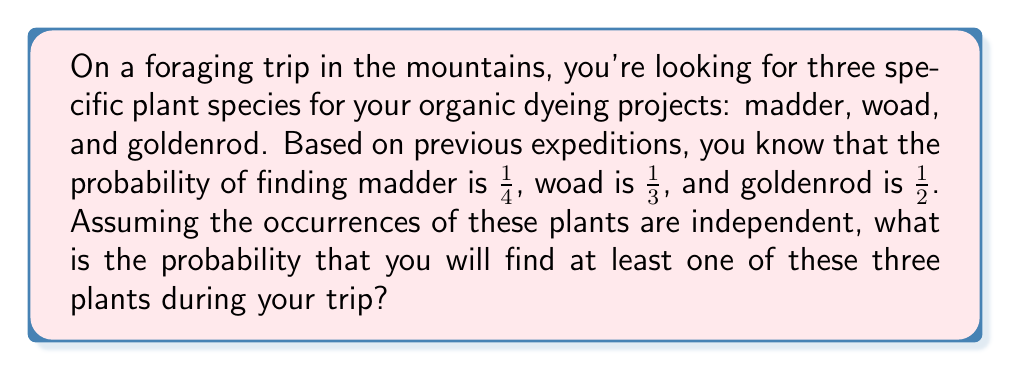Show me your answer to this math problem. Let's approach this step-by-step:

1) First, let's define our events:
   M: Finding madder
   W: Finding woad
   G: Finding goldenrod

2) We're given the probabilities:
   $P(M) = \frac{1}{4}$
   $P(W) = \frac{1}{3}$
   $P(G) = \frac{1}{2}$

3) We want to find the probability of finding at least one of these plants. It's easier to calculate the probability of not finding any of them and then subtract that from 1.

4) The probability of not finding a specific plant is the complement of finding it:
   $P(\text{not M}) = 1 - P(M) = 1 - \frac{1}{4} = \frac{3}{4}$
   $P(\text{not W}) = 1 - P(W) = 1 - \frac{1}{3} = \frac{2}{3}$
   $P(\text{not G}) = 1 - P(G) = 1 - \frac{1}{2} = \frac{1}{2}$

5) The probability of not finding any of the plants is the product of these probabilities (since the events are independent):

   $P(\text{none}) = P(\text{not M}) \times P(\text{not W}) \times P(\text{not G})$
   
   $= \frac{3}{4} \times \frac{2}{3} \times \frac{1}{2}$
   
   $= \frac{1}{4}$

6) Therefore, the probability of finding at least one of the plants is:

   $P(\text{at least one}) = 1 - P(\text{none}) = 1 - \frac{1}{4} = \frac{3}{4}$
Answer: $\frac{3}{4}$ 